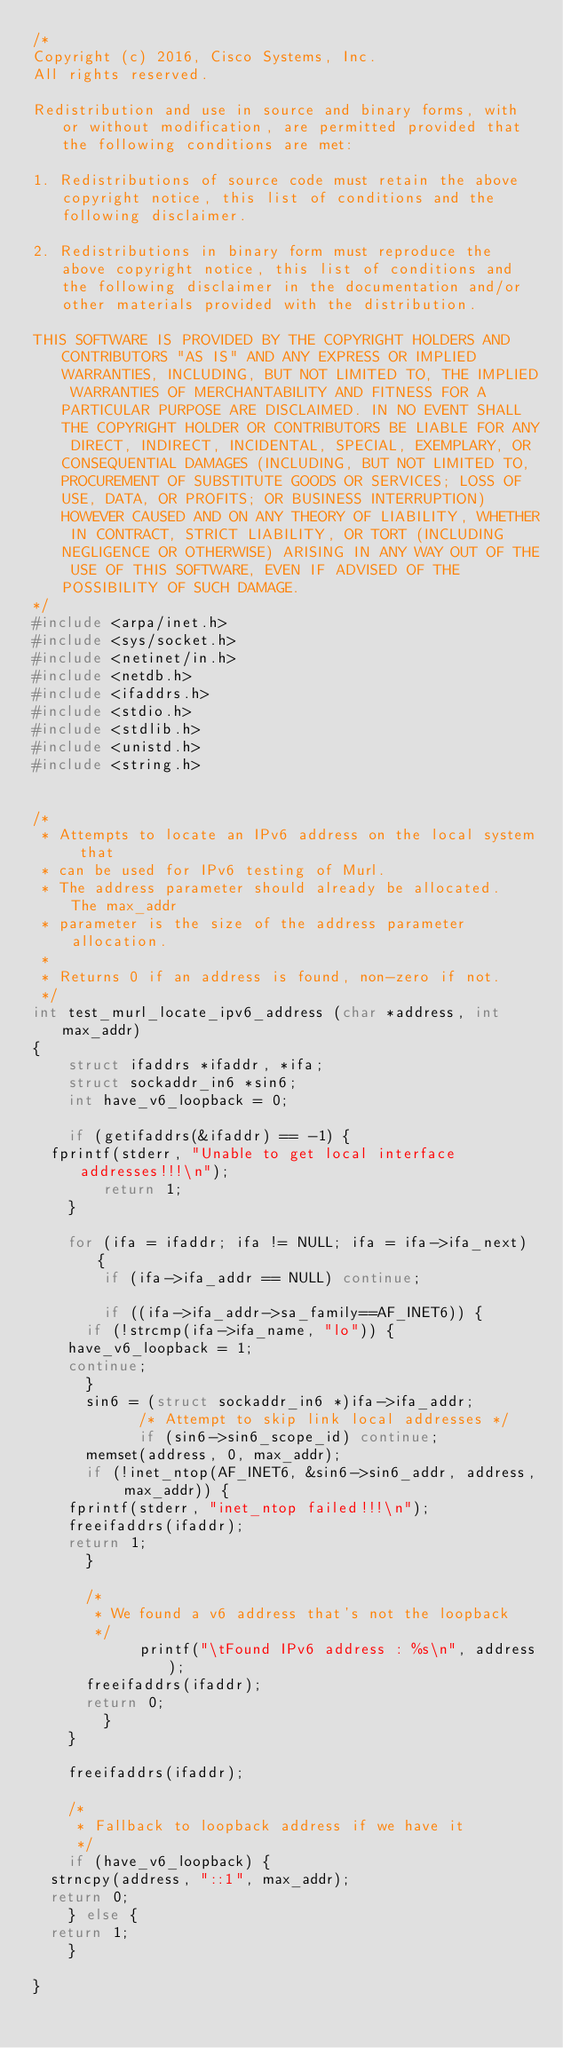<code> <loc_0><loc_0><loc_500><loc_500><_C_>/*
Copyright (c) 2016, Cisco Systems, Inc.
All rights reserved.

Redistribution and use in source and binary forms, with or without modification, are permitted provided that the following conditions are met:

1. Redistributions of source code must retain the above copyright notice, this list of conditions and the following disclaimer.

2. Redistributions in binary form must reproduce the above copyright notice, this list of conditions and the following disclaimer in the documentation and/or other materials provided with the distribution.

THIS SOFTWARE IS PROVIDED BY THE COPYRIGHT HOLDERS AND CONTRIBUTORS "AS IS" AND ANY EXPRESS OR IMPLIED WARRANTIES, INCLUDING, BUT NOT LIMITED TO, THE IMPLIED WARRANTIES OF MERCHANTABILITY AND FITNESS FOR A PARTICULAR PURPOSE ARE DISCLAIMED. IN NO EVENT SHALL THE COPYRIGHT HOLDER OR CONTRIBUTORS BE LIABLE FOR ANY DIRECT, INDIRECT, INCIDENTAL, SPECIAL, EXEMPLARY, OR CONSEQUENTIAL DAMAGES (INCLUDING, BUT NOT LIMITED TO, PROCUREMENT OF SUBSTITUTE GOODS OR SERVICES; LOSS OF USE, DATA, OR PROFITS; OR BUSINESS INTERRUPTION) HOWEVER CAUSED AND ON ANY THEORY OF LIABILITY, WHETHER IN CONTRACT, STRICT LIABILITY, OR TORT (INCLUDING NEGLIGENCE OR OTHERWISE) ARISING IN ANY WAY OUT OF THE USE OF THIS SOFTWARE, EVEN IF ADVISED OF THE POSSIBILITY OF SUCH DAMAGE.
*/
#include <arpa/inet.h>
#include <sys/socket.h>
#include <netinet/in.h>
#include <netdb.h>
#include <ifaddrs.h>
#include <stdio.h>
#include <stdlib.h>
#include <unistd.h>
#include <string.h>


/*
 * Attempts to locate an IPv6 address on the local system that
 * can be used for IPv6 testing of Murl.
 * The address parameter should already be allocated.  The max_addr
 * parameter is the size of the address parameter allocation.
 *
 * Returns 0 if an address is found, non-zero if not.
 */
int test_murl_locate_ipv6_address (char *address, int max_addr)
{
    struct ifaddrs *ifaddr, *ifa;
    struct sockaddr_in6 *sin6;
    int have_v6_loopback = 0;

    if (getifaddrs(&ifaddr) == -1) {
	fprintf(stderr, "Unable to get local interface addresses!!!\n");
        return 1;
    }

    for (ifa = ifaddr; ifa != NULL; ifa = ifa->ifa_next) {
        if (ifa->ifa_addr == NULL) continue;  

        if ((ifa->ifa_addr->sa_family==AF_INET6)) {
	    if (!strcmp(ifa->ifa_name, "lo")) {
		have_v6_loopback = 1;
		continue;
	    }
	    sin6 = (struct sockaddr_in6 *)ifa->ifa_addr;
            /* Attempt to skip link local addresses */
            if (sin6->sin6_scope_id) continue;
	    memset(address, 0, max_addr);
	    if (!inet_ntop(AF_INET6, &sin6->sin6_addr, address, max_addr)) {
		fprintf(stderr, "inet_ntop failed!!!\n");
		freeifaddrs(ifaddr);
		return 1;
	    }

	    /*
	     * We found a v6 address that's not the loopback
	     */
            printf("\tFound IPv6 address : %s\n", address); 
	    freeifaddrs(ifaddr);
	    return 0;
        }
    }

    freeifaddrs(ifaddr);

    /*
     * Fallback to loopback address if we have it
     */
    if (have_v6_loopback) {
	strncpy(address, "::1", max_addr);
	return 0;
    } else {
	return 1;
    }

}
</code> 